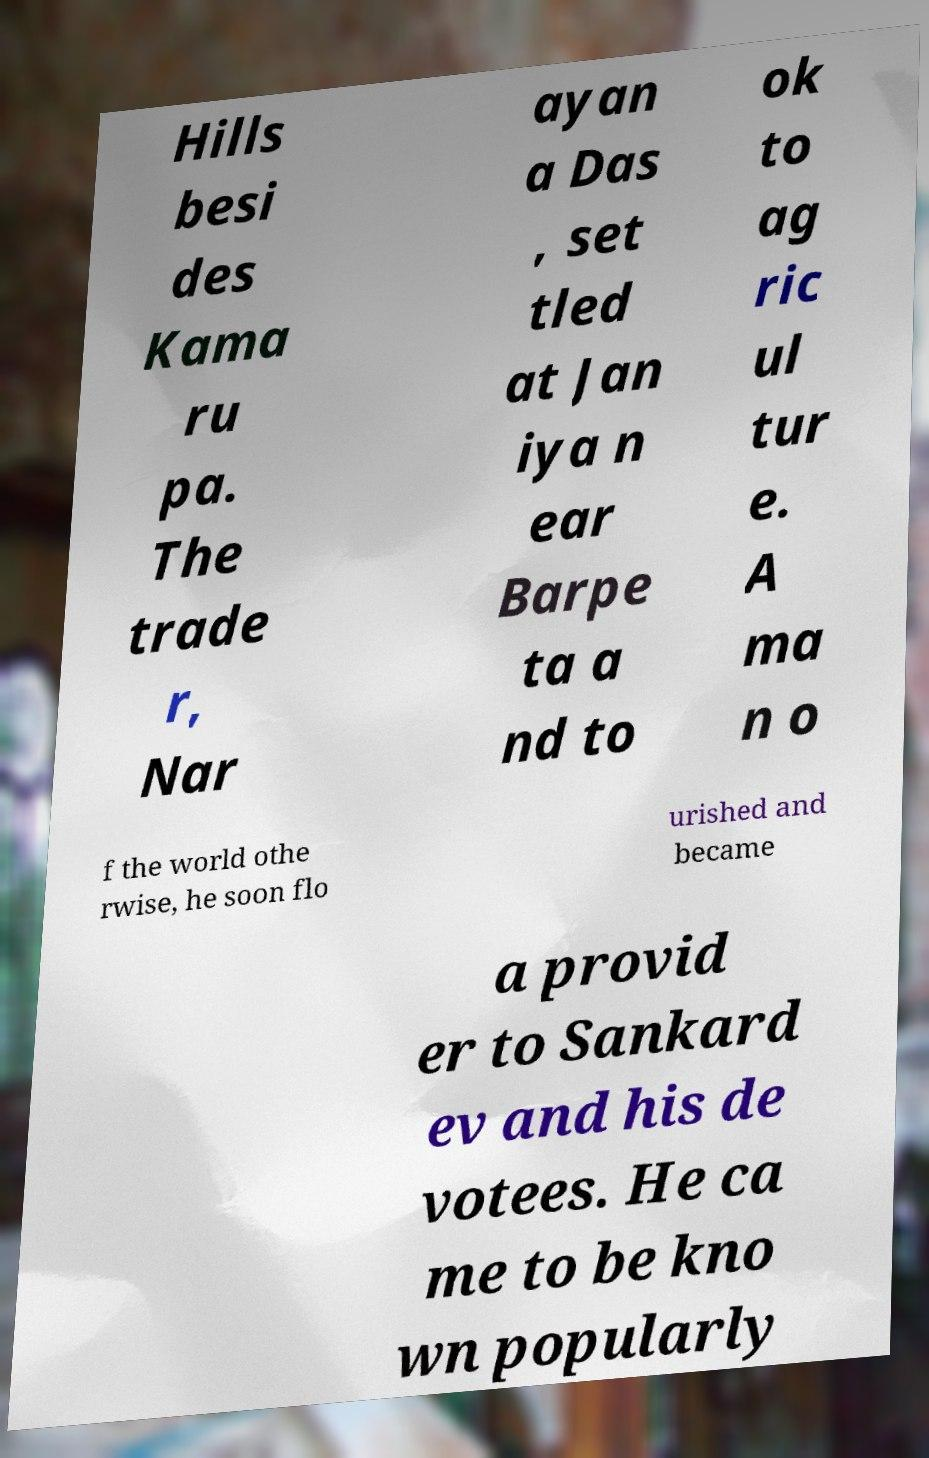Can you accurately transcribe the text from the provided image for me? Hills besi des Kama ru pa. The trade r, Nar ayan a Das , set tled at Jan iya n ear Barpe ta a nd to ok to ag ric ul tur e. A ma n o f the world othe rwise, he soon flo urished and became a provid er to Sankard ev and his de votees. He ca me to be kno wn popularly 